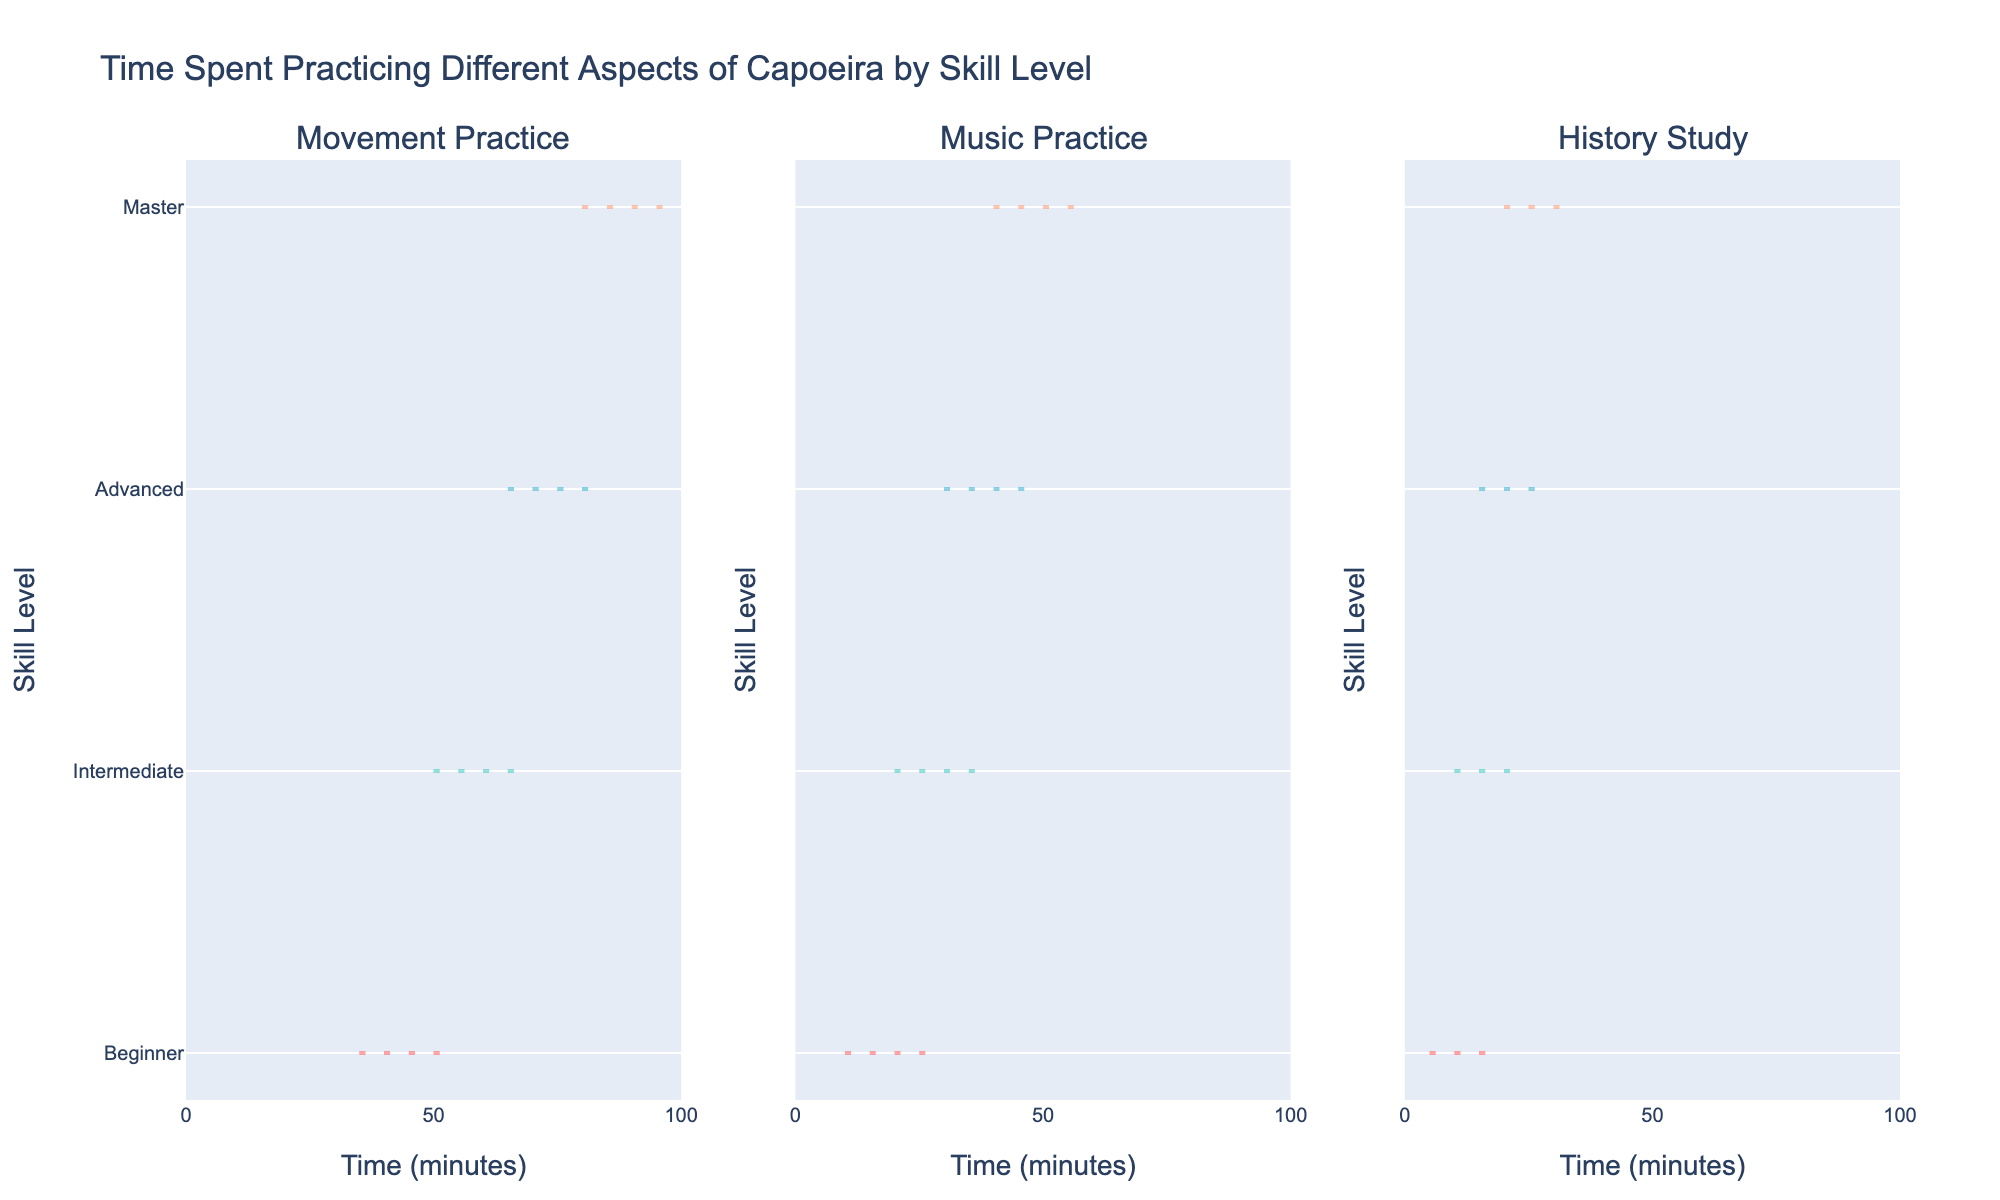What's the title of the figure? The title is typically located at the top of the figure. Here, it reads: "Time Spent Practicing Different Aspects of Capoeira by Skill Level".
Answer: Time Spent Practicing Different Aspects of Capoeira by Skill Level Which skill level has the lowest amount of time spent on movement practice? By looking at the violin plots representing movement practice, the beginner level shows the lowest amount of time with the violin plot's lower end around 35 minutes.
Answer: Beginner How does time spent on music practice compare between Intermediate and Advanced skill levels? By comparing the central tendency and spread of the violin plots for Intermediate and Advanced in music practice, Advanced shows higher times, with ranges extending upwards of 35-45 minutes, while Intermediate centers around 20-30 minutes.
Answer: Advanced On average, how much more time do Masters spend on history study compared to Beginners? Examining the violin plots for history study, Masters typically range around 20-30 minutes, while Beginners hover around 5-15 minutes. Estimating the averages, Masters spend approximately 25 minutes, and Beginners 10 minutes. The difference is about 15 minutes.
Answer: 15 minutes Which skill level shows the widest range of time spent on music practice? The "Music Practice" subplot’s violin plots should be examined. The Master skill level shows the widest range of times, spanning from roughly 40 to 55 minutes, which is wider than other levels.
Answer: Master What is the general trend in time spent practicing movements as skill level increases? By looking at the violin plots for movement practice across skill levels, there's a clear upward trend where time spent increases as the skill level rises from Beginner to Master.
Answer: Increases Which practice type has the least variance in time spent by Intermediate skill level? By comparing the violin plots for Intermediate across all practice types, the range for Music Practice appears narrower (20-35 minutes) compared to Movement (50-65 minutes) and History Study (10-20 minutes).
Answer: Music Practice How does the median time spent on movement practice for Masters compare to the median for Advanced? Observing the center line of the violin plots for Masters and Advanced in movement practice, Masters' median is higher, likely around 90 minutes, whereas Advanced is around 75 minutes.
Answer: Master higher Is there more overlap in the times spent on history study between Beginner and Intermediate or between Advanced and Master? By comparing the violin plots, Beginner and Intermediate have a clear overlap around 10-15 minutes, whereas Advanced and Master overlap more around 20-25 minutes, indicating more overlap at the higher skill levels.
Answer: Advanced and Master Which skill level has the closest median times for all three practice types? Examining the center peaks in each practice type's subplot, Intermediate skill level shows relatively close medians: Movements (60 minutes), Music (30 minutes), and History (15 minutes), compared to other levels.
Answer: Intermediate 